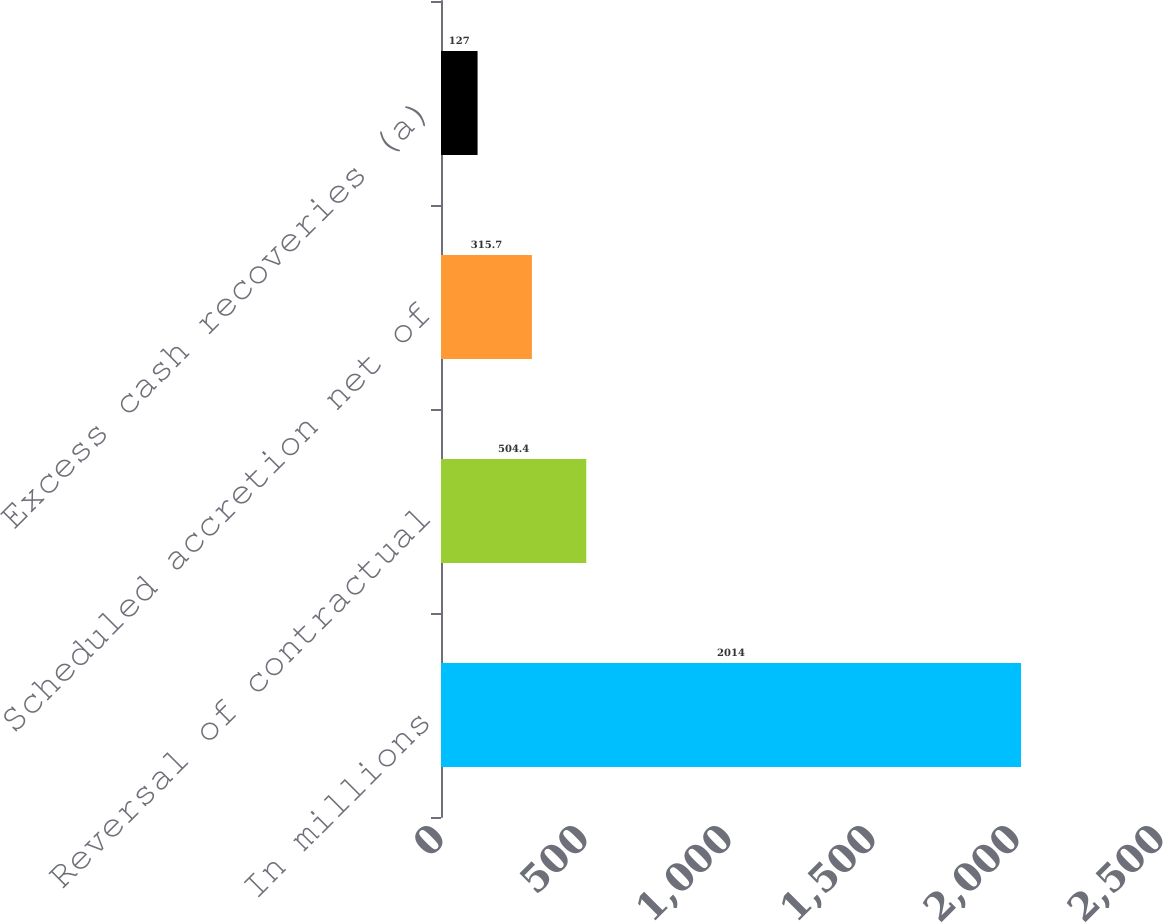Convert chart to OTSL. <chart><loc_0><loc_0><loc_500><loc_500><bar_chart><fcel>In millions<fcel>Reversal of contractual<fcel>Scheduled accretion net of<fcel>Excess cash recoveries (a)<nl><fcel>2014<fcel>504.4<fcel>315.7<fcel>127<nl></chart> 